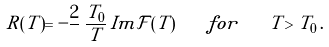<formula> <loc_0><loc_0><loc_500><loc_500>R ( T ) = - \frac { 2 } { } \, \frac { T _ { 0 } } { T } \, I m \mathcal { F } ( T ) \quad f o r \quad T > T _ { 0 } \, .</formula> 